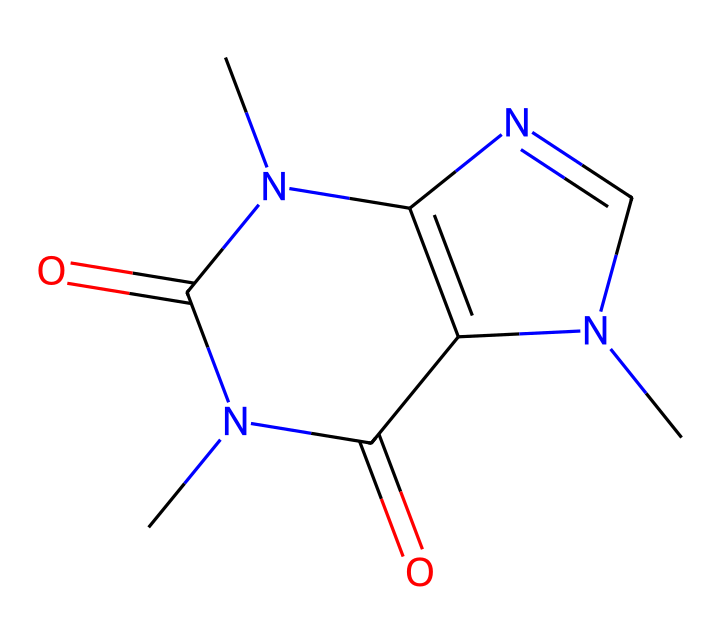What is the molecular formula of caffeine? The molecular formula can be determined by counting the number of each type of atom present in the SMILES representation. In this case, there are 8 carbon (C) atoms, 10 hydrogen (H) atoms, 4 nitrogen (N) atoms, and 2 oxygen (O) atoms. Thus, the molecular formula is C8H10N4O2.
Answer: C8H10N4O2 How many nitrogen atoms are in the caffeine structure? By analyzing the provided SMILES, we observe that there are four instances of nitrogen notation (N). Each of these represents a nitrogen atom, so the total count is four.
Answer: 4 What type of functional groups can be identified in caffeine? In the chemical structure of caffeine, we can identify carbonyl groups (C=O) and amine groups (–NH) associated with the nitrogen atoms. These groups are quite common in molecules with stimulant properties.
Answer: carbonyl and amine What is the primary class of compounds that caffeine belongs to? Caffeine is categorized as an alkaloid, which is a class of nitrogen-containing compounds. The presence of multiple nitrogen atoms in its structure confirms its classification as an alkaloid.
Answer: alkaloid How does the chemical structure of caffeine contribute to its stimulant effects? The nitrogen atoms in caffeine are involved in forming hydrogen bonds with adenosine receptors in the brain. This interaction leads to increased alertness and reduced fatigue, characteristic of stimulants. The systematic arrangement of the nitrogen and carbon atoms in the structure facilitates this interaction.
Answer: nitrogen atoms Which part of the caffeine structure is associated with its bitter taste? The presence of nitrogen atoms within the alkaloid framework contributes to its characteristic bitter taste. Alkaloids, including caffeine, are known for this property due to their interaction with taste receptors.
Answer: nitrogen atoms 